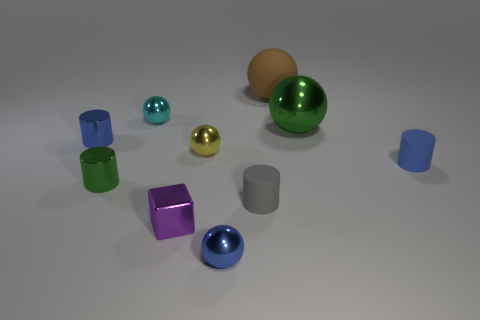What shape is the metallic thing that is both in front of the green sphere and behind the tiny yellow thing? The object in question is a metallic cylinder. Positioned between the green sphere, which takes center stage, and a diminutive yellow object, the cylinder reflects light beautifully, highlighting its pristine, circular cross-section and elongated structure characteristic of cylindrical shapes. 